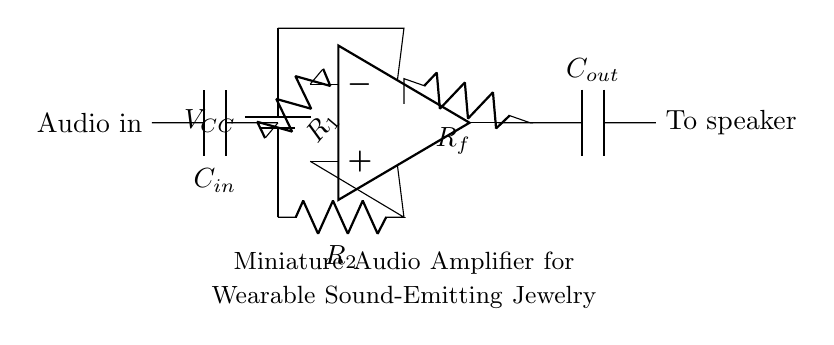What is the power supply voltage in this circuit? The schematic indicates a battery labeled as V_Cc connected to the circuit. Typically, the voltage for a battery is designated next to it. However, the exact number is not specified here.
Answer: V_Cc What does R_1 connect to? In the circuit diagram, R_1 connects to the inverting input of the operational amplifier and to the audio input point. This shows that it plays a role in setting gain in relation to the input signal.
Answer: The inverting input What is the role of C_in? C_in is connected in series with the audio input and R_1, suggesting it filters DC components, allowing only AC signals (audio signals) to pass to the operational amplifier for amplification.
Answer: Coupling capacitor How many resistors are present in the circuit? By counting the components in the diagram, we see three resistors labeled R_1, R_2, and R_f, totaling three resistive components in this amplifier configuration.
Answer: Three What type of circuit is this? The circuit diagram clearly shows that it consists of an operational amplifier with feedback components, classifying it as an audio amplifier circuit suitable for wearable applications.
Answer: Audio amplifier What is connected to the output of the op-amp? The output of the op-amp connects to a capacitor labeled C_out, which then connects to the speaker, indicating the amplified audio output is prepared for driving the speaker.
Answer: A capacitor (C_out) What is the function of R_f in the circuit? R_f is part of the feedback network that returns a portion of the output signal to the inverting input, which is essential for setting the gain of the amplifier, influencing how much the input signal is amplified.
Answer: Feedback resistor 